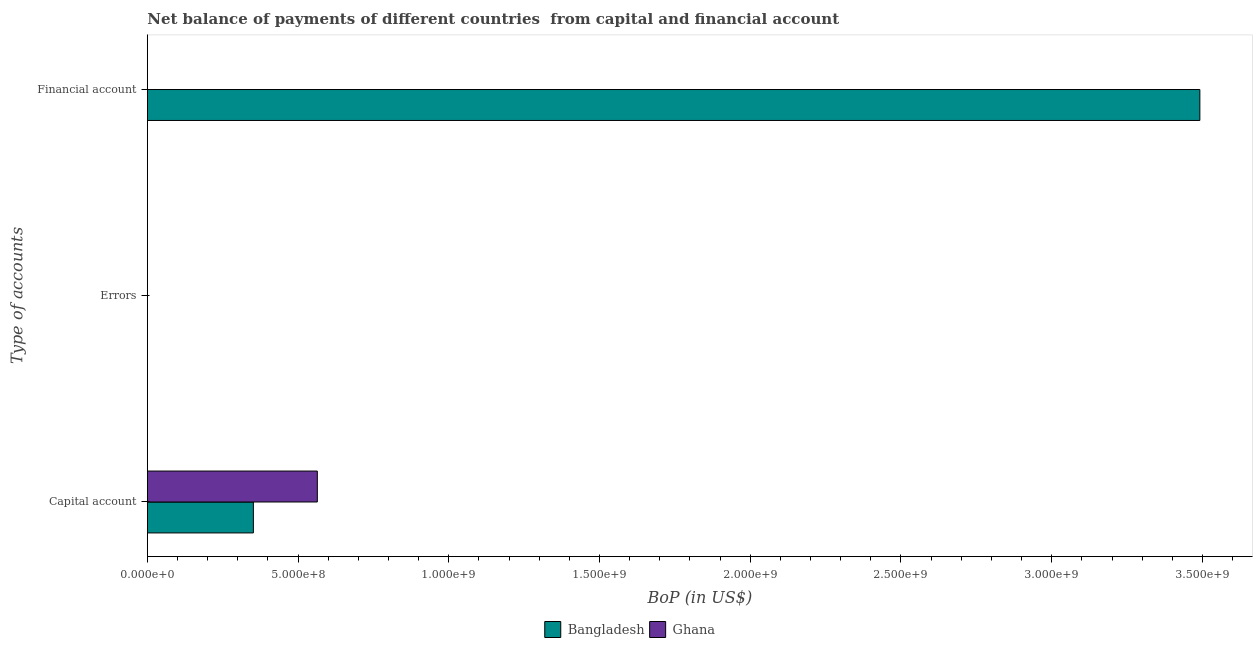How many different coloured bars are there?
Make the answer very short. 2. Are the number of bars per tick equal to the number of legend labels?
Offer a terse response. No. Are the number of bars on each tick of the Y-axis equal?
Provide a short and direct response. No. How many bars are there on the 3rd tick from the top?
Your response must be concise. 2. How many bars are there on the 1st tick from the bottom?
Offer a terse response. 2. What is the label of the 2nd group of bars from the top?
Your answer should be compact. Errors. What is the amount of financial account in Bangladesh?
Give a very brief answer. 3.49e+09. Across all countries, what is the maximum amount of net capital account?
Your answer should be compact. 5.64e+08. What is the total amount of net capital account in the graph?
Your answer should be compact. 9.16e+08. What is the difference between the amount of net capital account in Ghana and that in Bangladesh?
Provide a succinct answer. 2.12e+08. What is the difference between the amount of financial account in Bangladesh and the amount of errors in Ghana?
Your response must be concise. 3.49e+09. What is the average amount of financial account per country?
Keep it short and to the point. 1.75e+09. What is the difference between the amount of net capital account and amount of financial account in Bangladesh?
Your answer should be compact. -3.14e+09. In how many countries, is the amount of net capital account greater than 2600000000 US$?
Provide a short and direct response. 0. What is the ratio of the amount of net capital account in Ghana to that in Bangladesh?
Provide a short and direct response. 1.6. What is the difference between the highest and the lowest amount of financial account?
Ensure brevity in your answer.  3.49e+09. Is the sum of the amount of net capital account in Bangladesh and Ghana greater than the maximum amount of financial account across all countries?
Offer a very short reply. No. Is it the case that in every country, the sum of the amount of net capital account and amount of errors is greater than the amount of financial account?
Offer a terse response. No. Are all the bars in the graph horizontal?
Provide a succinct answer. Yes. Are the values on the major ticks of X-axis written in scientific E-notation?
Offer a very short reply. Yes. Where does the legend appear in the graph?
Give a very brief answer. Bottom center. How many legend labels are there?
Make the answer very short. 2. What is the title of the graph?
Your answer should be very brief. Net balance of payments of different countries  from capital and financial account. Does "Vanuatu" appear as one of the legend labels in the graph?
Ensure brevity in your answer.  No. What is the label or title of the X-axis?
Offer a terse response. BoP (in US$). What is the label or title of the Y-axis?
Your answer should be very brief. Type of accounts. What is the BoP (in US$) in Bangladesh in Capital account?
Provide a short and direct response. 3.52e+08. What is the BoP (in US$) in Ghana in Capital account?
Your answer should be compact. 5.64e+08. What is the BoP (in US$) of Bangladesh in Financial account?
Make the answer very short. 3.49e+09. What is the BoP (in US$) in Ghana in Financial account?
Offer a very short reply. 0. Across all Type of accounts, what is the maximum BoP (in US$) of Bangladesh?
Ensure brevity in your answer.  3.49e+09. Across all Type of accounts, what is the maximum BoP (in US$) in Ghana?
Your answer should be very brief. 5.64e+08. Across all Type of accounts, what is the minimum BoP (in US$) in Ghana?
Provide a short and direct response. 0. What is the total BoP (in US$) in Bangladesh in the graph?
Your answer should be very brief. 3.84e+09. What is the total BoP (in US$) of Ghana in the graph?
Provide a succinct answer. 5.64e+08. What is the difference between the BoP (in US$) in Bangladesh in Capital account and that in Financial account?
Offer a very short reply. -3.14e+09. What is the average BoP (in US$) of Bangladesh per Type of accounts?
Give a very brief answer. 1.28e+09. What is the average BoP (in US$) in Ghana per Type of accounts?
Your response must be concise. 1.88e+08. What is the difference between the BoP (in US$) in Bangladesh and BoP (in US$) in Ghana in Capital account?
Offer a very short reply. -2.12e+08. What is the ratio of the BoP (in US$) of Bangladesh in Capital account to that in Financial account?
Offer a terse response. 0.1. What is the difference between the highest and the lowest BoP (in US$) in Bangladesh?
Your answer should be very brief. 3.49e+09. What is the difference between the highest and the lowest BoP (in US$) of Ghana?
Your answer should be compact. 5.64e+08. 